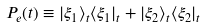Convert formula to latex. <formula><loc_0><loc_0><loc_500><loc_500>P _ { e } ( t ) \equiv | \xi _ { 1 } \rangle _ { t } \langle \xi _ { 1 } | _ { t } + | \xi _ { 2 } \rangle _ { t } \langle \xi _ { 2 } | _ { t }</formula> 